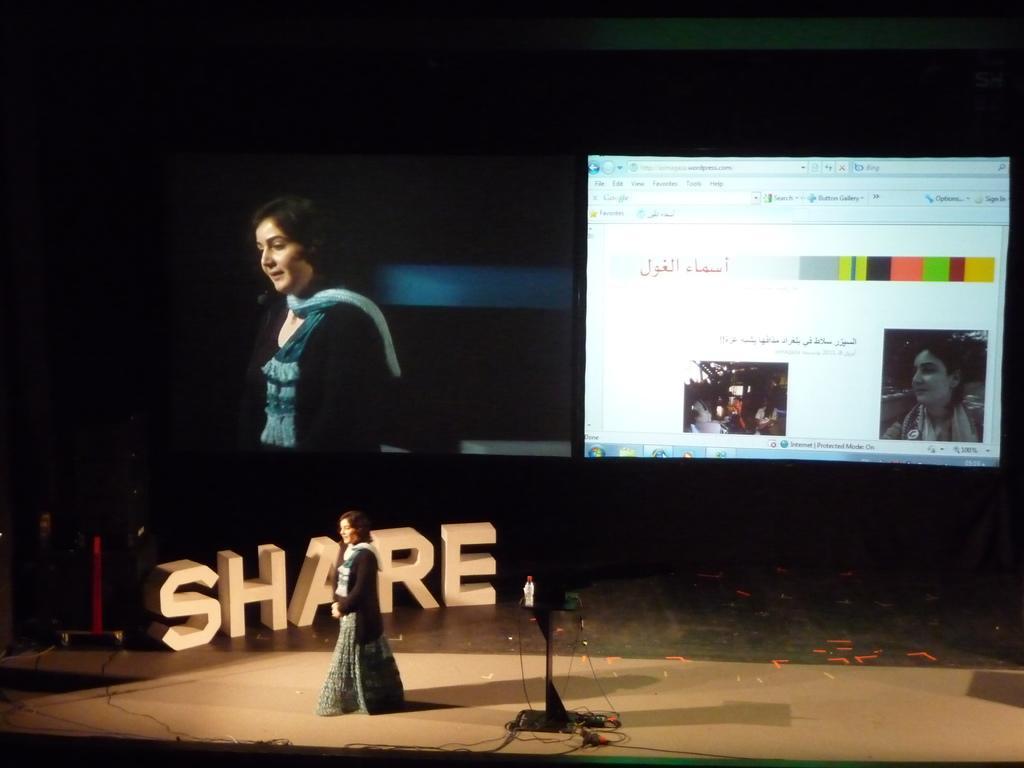In one or two sentences, can you explain what this image depicts? This is collage image in this image there is a lady standing on a stage, in the background there is text and in another image there is a lady and a monitor. 